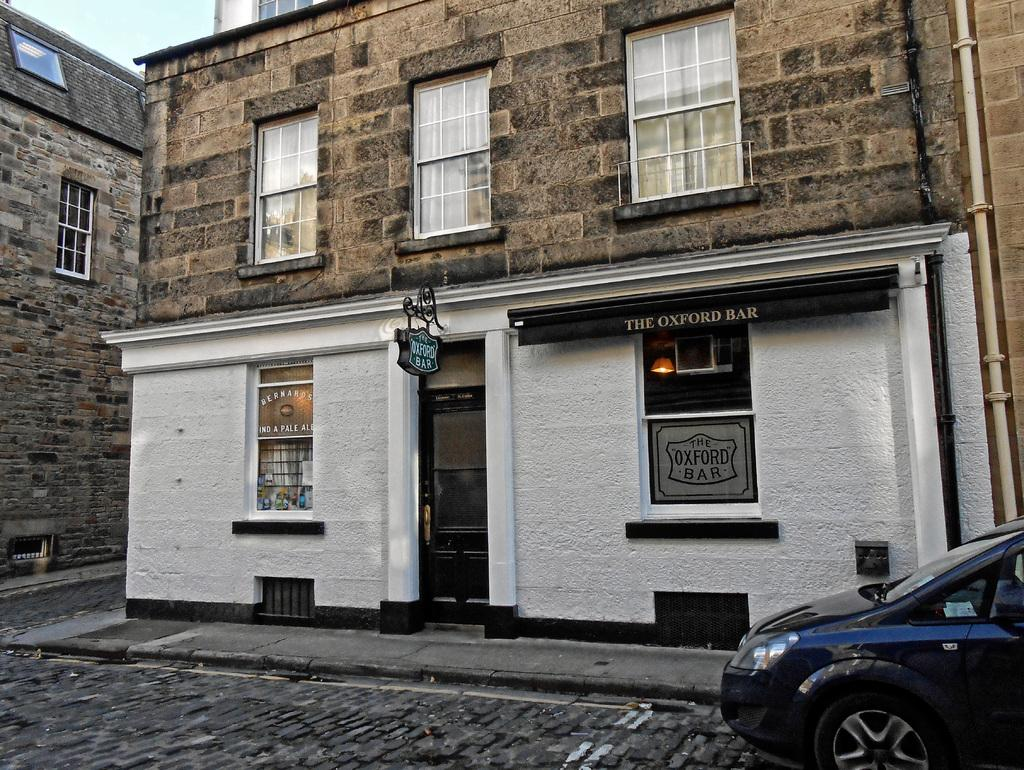What type of structures can be seen in the image? There are buildings in the image. What architectural features are present on the buildings? There are windows and a door visible in the image. What type of vehicle is present in the image? There is a blue color car in the image. What is visible at the top of the image? The sky is visible at the top of the image. What type of army is depicted in the image? There is no army present in the image; it features buildings, windows, a door, a blue color car, and a visible sky. 